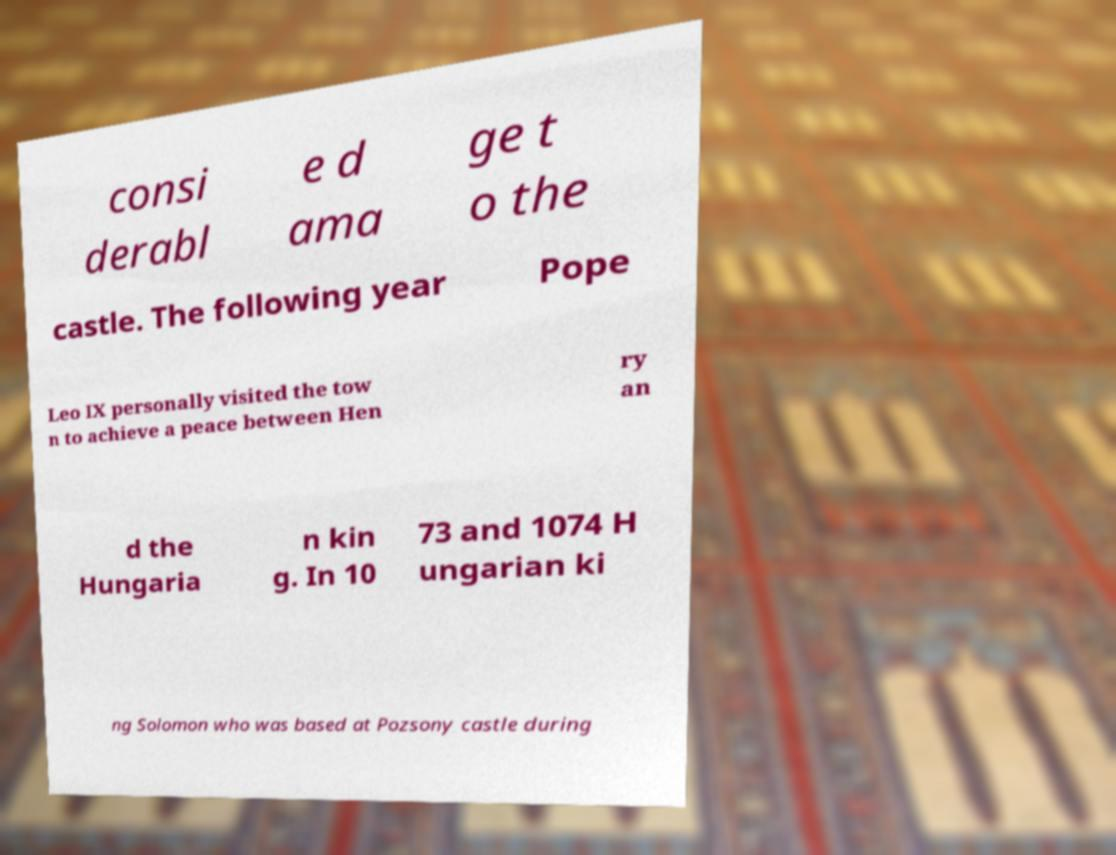For documentation purposes, I need the text within this image transcribed. Could you provide that? consi derabl e d ama ge t o the castle. The following year Pope Leo IX personally visited the tow n to achieve a peace between Hen ry an d the Hungaria n kin g. In 10 73 and 1074 H ungarian ki ng Solomon who was based at Pozsony castle during 